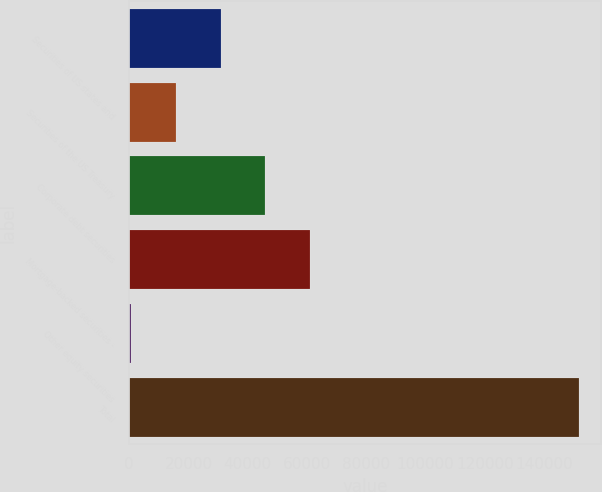Convert chart to OTSL. <chart><loc_0><loc_0><loc_500><loc_500><bar_chart><fcel>Securities of US states and<fcel>Securities of the US Treasury<fcel>Corporate debt securities<fcel>Mortgage-backed securities -<fcel>Other equity securities<fcel>Total<nl><fcel>30888.2<fcel>15777.1<fcel>45999.3<fcel>61110.4<fcel>666<fcel>151777<nl></chart> 